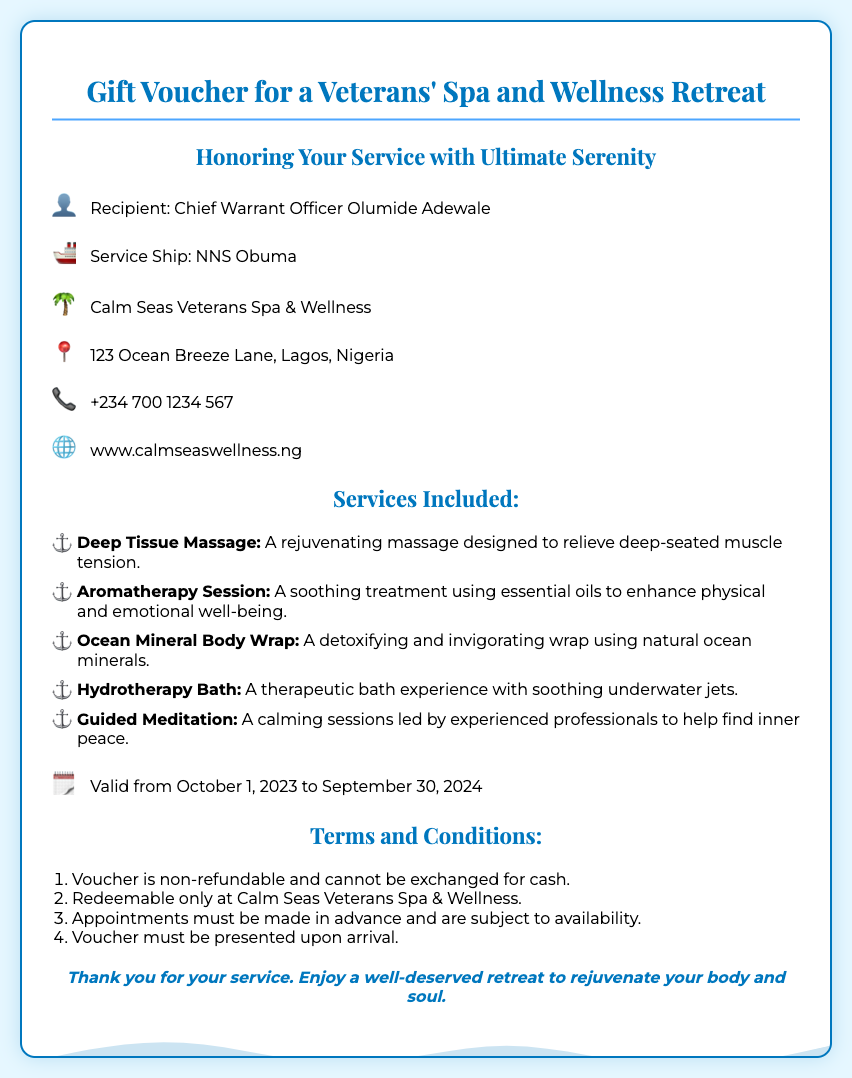What is the recipient's name? The recipient's name is stated at the top of the document in the recipient section.
Answer: Chief Warrant Officer Olumide Adewale What is the service ship mentioned? The service ship is listed in the same section as the recipient's name.
Answer: NNS Obuma Which spa is mentioned in the voucher? The name of the spa is provided in the retreat information section.
Answer: Calm Seas Veterans Spa & Wellness What is the contact number for the spa? The contact number is included in the retreat information for inquiries.
Answer: +234 700 1234 567 What services are included? The services are listed under the services included section, specifically detailing the spa offerings.
Answer: Deep Tissue Massage, Aromatherapy Session, Ocean Mineral Body Wrap, Hydrotherapy Bath, Guided Meditation What is the validity period of the voucher? The validity period is specified in a dedicated section of the document.
Answer: October 1, 2023 to September 30, 2024 How many terms and conditions are listed? The number of terms is determined by counting the list items in the terms and conditions section.
Answer: Four Is the voucher refundable? The refund policy is part of the terms and conditions presented in the document.
Answer: No What is the special message for the recipient? The special message is given at the bottom of the voucher to convey appreciation.
Answer: Thank you for your service. Enjoy a well-deserved retreat to rejuvenate your body and soul 